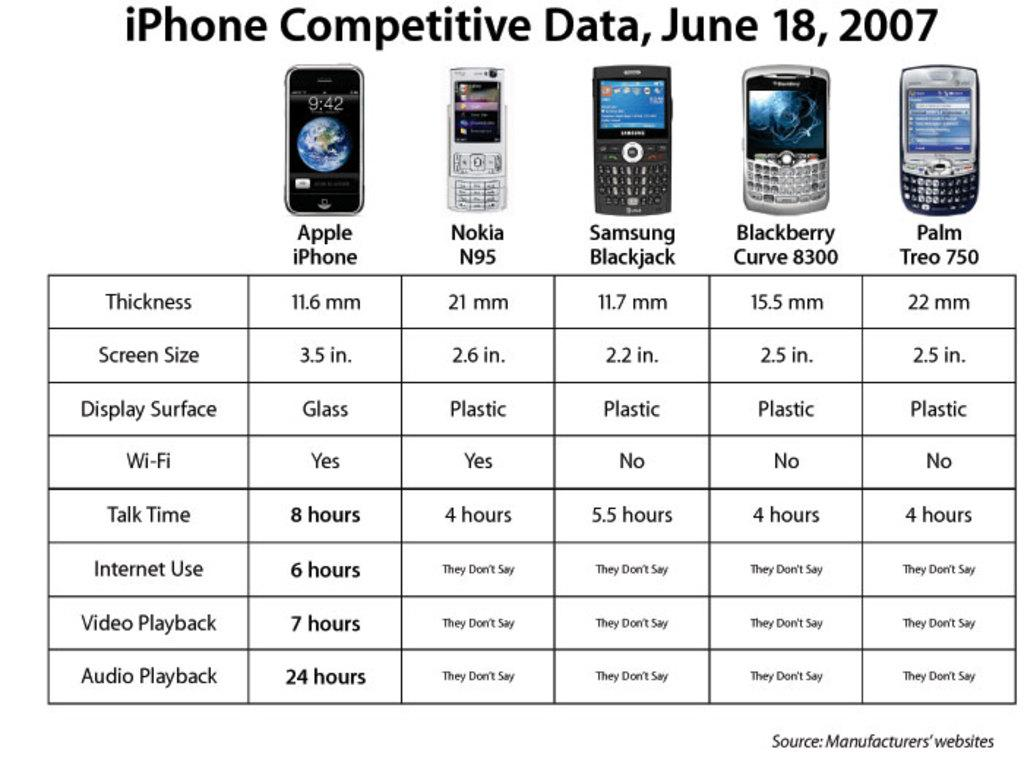<image>
Render a clear and concise summary of the photo. A chart, comparing several phones, is dated June 18, 2007. 